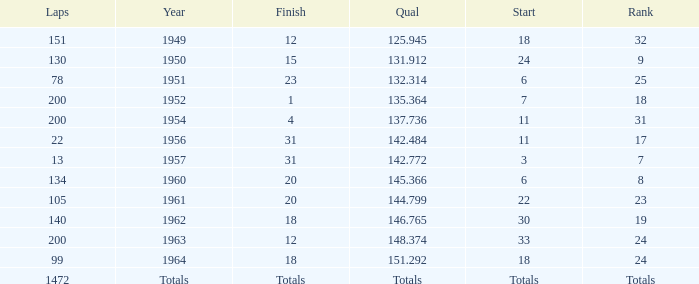Name the year for laps of 200 and rank of 24 1963.0. 